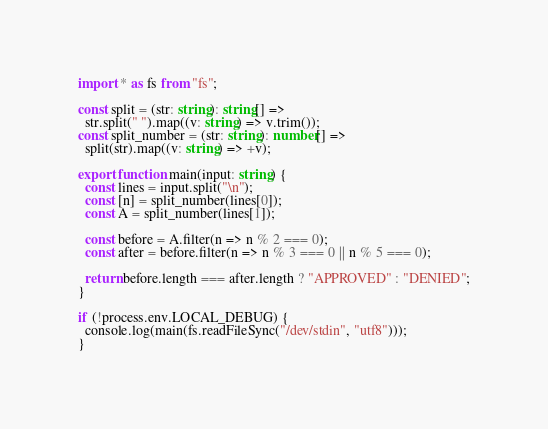Convert code to text. <code><loc_0><loc_0><loc_500><loc_500><_TypeScript_>import * as fs from "fs";

const split = (str: string): string[] =>
  str.split(" ").map((v: string) => v.trim());
const split_number = (str: string): number[] =>
  split(str).map((v: string) => +v);

export function main(input: string) {
  const lines = input.split("\n");
  const [n] = split_number(lines[0]);
  const A = split_number(lines[1]);

  const before = A.filter(n => n % 2 === 0);
  const after = before.filter(n => n % 3 === 0 || n % 5 === 0);

  return before.length === after.length ? "APPROVED" : "DENIED";
}

if (!process.env.LOCAL_DEBUG) {
  console.log(main(fs.readFileSync("/dev/stdin", "utf8")));
}
</code> 